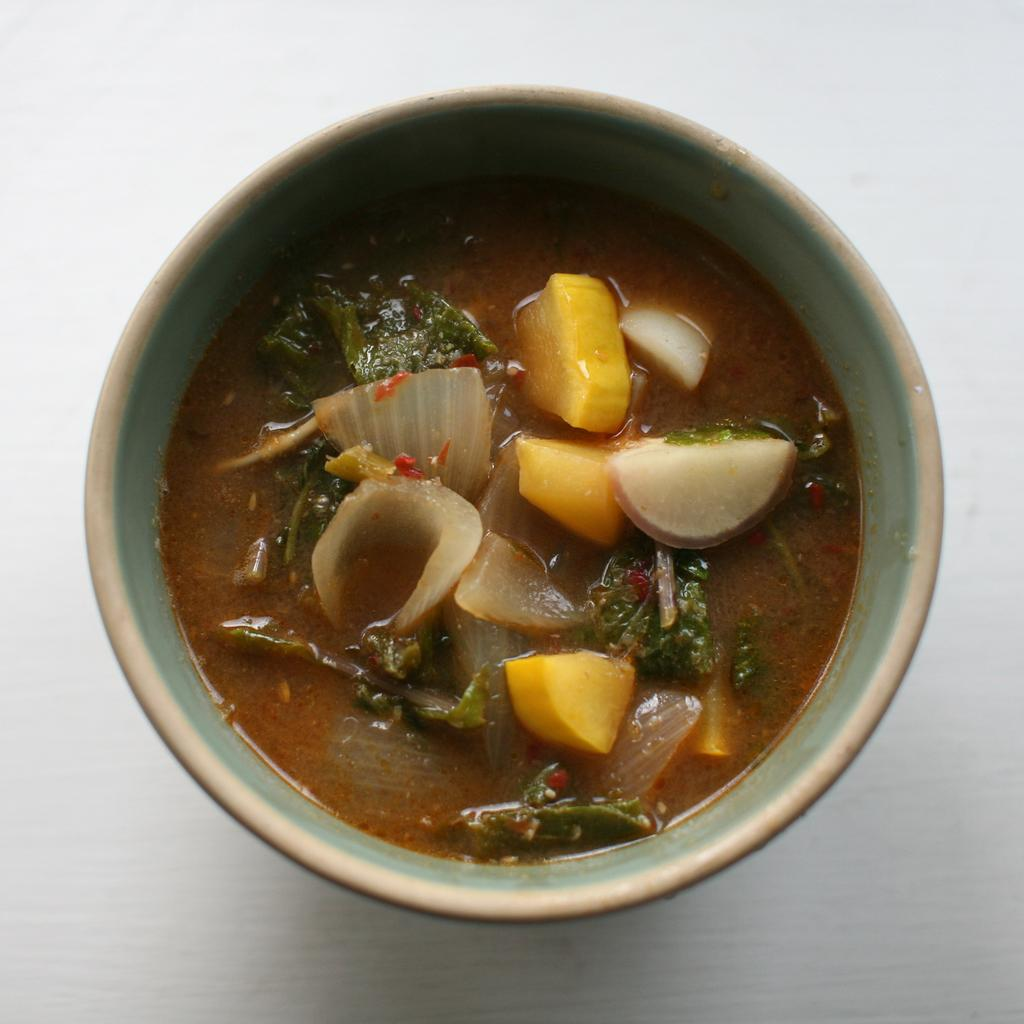What is in the bowl that is visible in the image? There is a bowl with food in the image. What is the color of the surface on which the bowl is placed? The bowl is placed on a white surface. What type of statement can be seen written on the basket in the image? There is no basket present in the image, and therefore no statement can be seen written on it. 